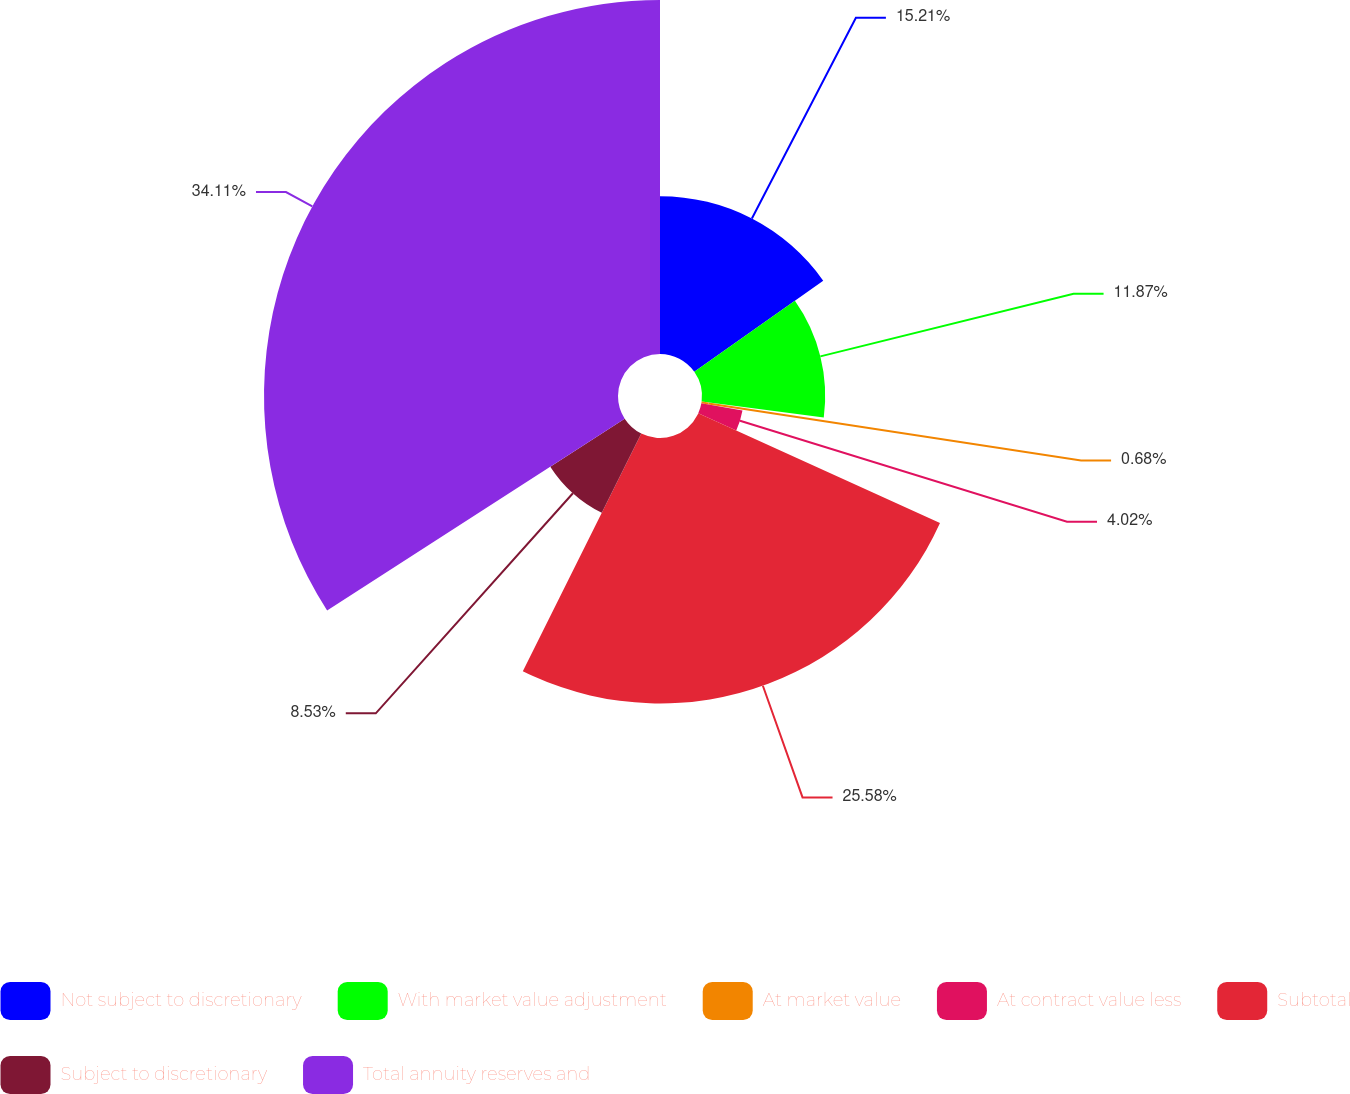Convert chart to OTSL. <chart><loc_0><loc_0><loc_500><loc_500><pie_chart><fcel>Not subject to discretionary<fcel>With market value adjustment<fcel>At market value<fcel>At contract value less<fcel>Subtotal<fcel>Subject to discretionary<fcel>Total annuity reserves and<nl><fcel>15.21%<fcel>11.87%<fcel>0.68%<fcel>4.02%<fcel>25.58%<fcel>8.53%<fcel>34.11%<nl></chart> 